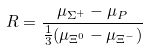Convert formula to latex. <formula><loc_0><loc_0><loc_500><loc_500>R = \frac { \mu _ { \Sigma ^ { + } } - \mu _ { P } } { \frac { 1 } { 3 } ( \mu _ { \Xi ^ { 0 } } - \mu _ { \Xi ^ { - } } ) }</formula> 